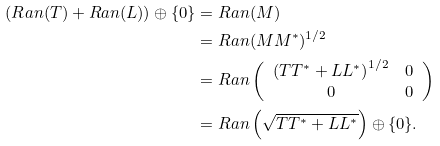Convert formula to latex. <formula><loc_0><loc_0><loc_500><loc_500>( R a n ( T ) + R a n ( L ) ) \oplus \{ 0 \} & = R a n ( M ) \\ & = R a n ( M M ^ { \ast } ) ^ { 1 / 2 } \\ & = R a n \left ( \begin{array} { c c } \left ( T T ^ { * } + L L ^ { * } \right ) ^ { 1 / 2 } & 0 \\ 0 & 0 \end{array} \right ) \\ & = R a n \left ( \sqrt { T T ^ { * } + L L ^ { * } } \right ) \oplus \{ 0 \} .</formula> 